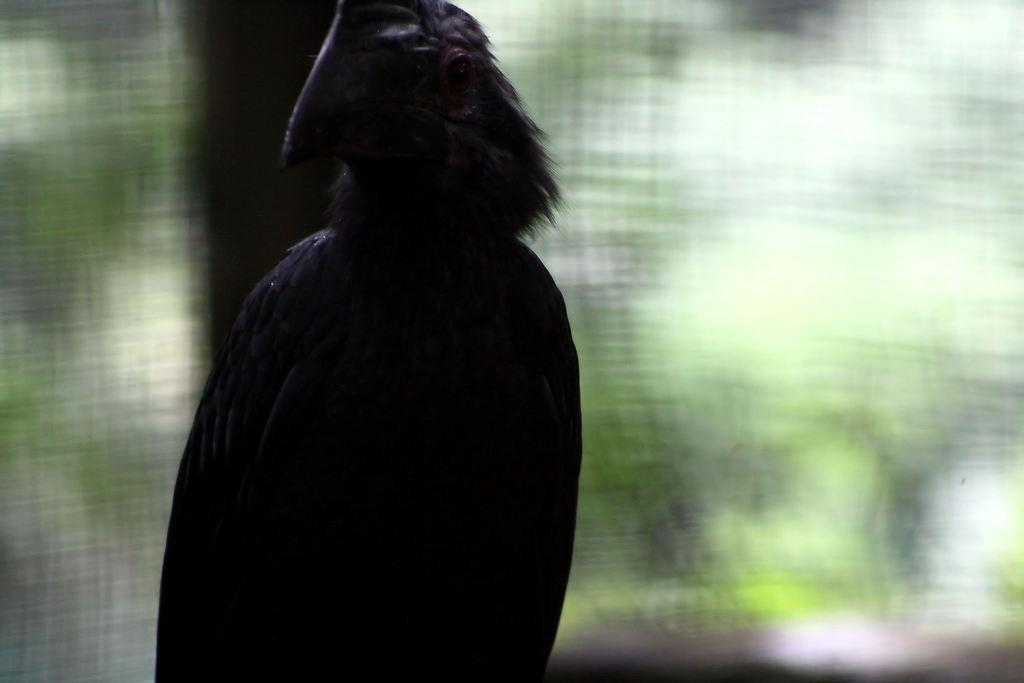What is the main subject of the image? There is a bird in the center of the image. Can you describe the background of the image? The background of the image is blurred. Where is the sink located in the image? There is no sink present in the image. What type of support can be seen holding up the bird in the image? There is no support holding up the bird in the image; it is likely flying or perched on its own. 